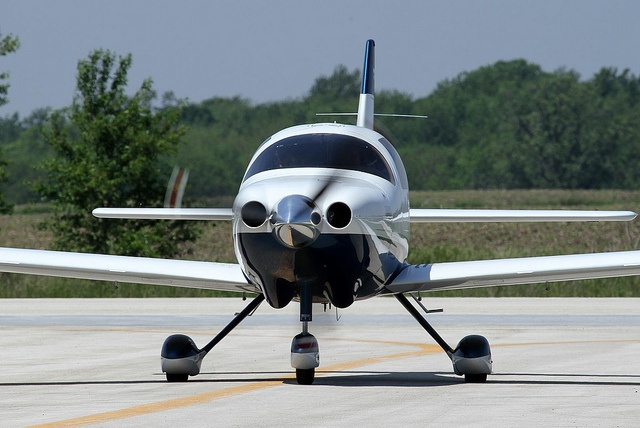Describe the objects in this image and their specific colors. I can see airplane in darkgray, black, white, and gray tones and people in darkgray, navy, black, darkblue, and gray tones in this image. 